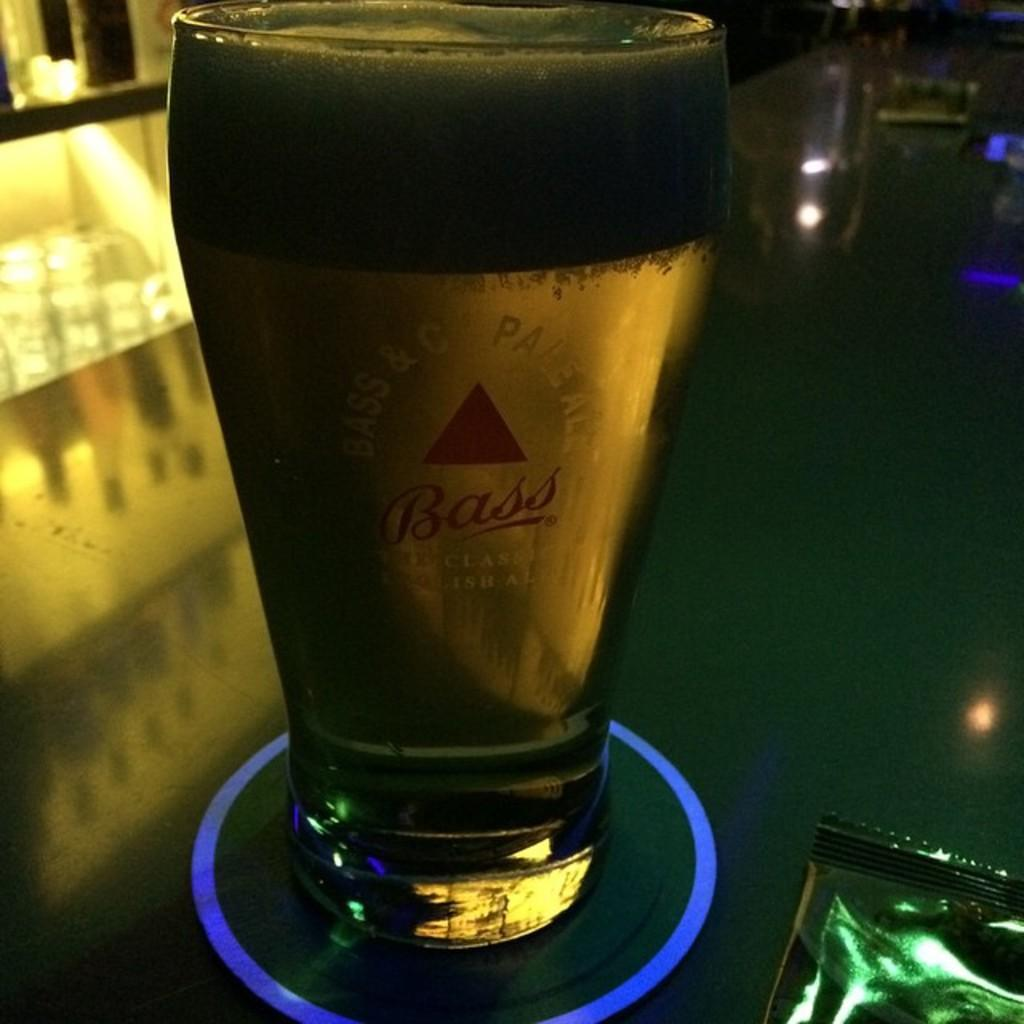What is in the glass that is visible in the image? There is a beverage in a glass in the image. Where is the glass located in the image? The glass is placed on a table. What type of shoes is the rat wearing in the image? There is no rat or shoes present in the image. 